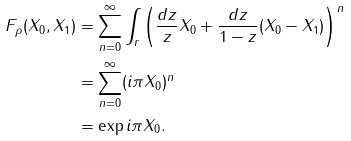Convert formula to latex. <formula><loc_0><loc_0><loc_500><loc_500>F _ { \rho } ( X _ { 0 } , X _ { 1 } ) & = \sum _ { n = 0 } ^ { \infty } \int _ { r } \left ( \frac { d z } { z } X _ { 0 } + \frac { d z } { 1 - z } ( X _ { 0 } - X _ { 1 } ) \right ) ^ { n } \\ & = \sum _ { n = 0 } ^ { \infty } ( i \pi X _ { 0 } ) ^ { n } \\ & = \exp i \pi X _ { 0 } .</formula> 